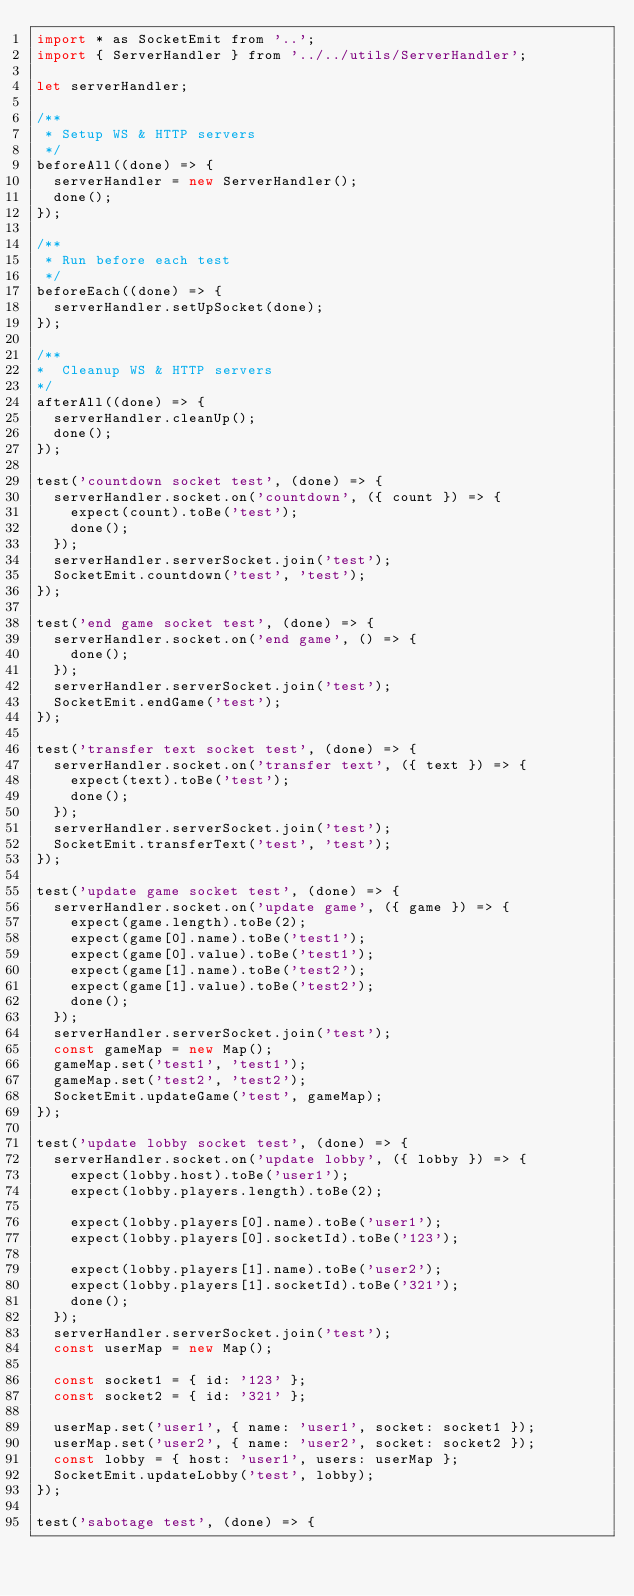<code> <loc_0><loc_0><loc_500><loc_500><_JavaScript_>import * as SocketEmit from '..';
import { ServerHandler } from '../../utils/ServerHandler';

let serverHandler;

/**
 * Setup WS & HTTP servers
 */
beforeAll((done) => {
  serverHandler = new ServerHandler();
  done();
});

/**
 * Run before each test
 */
beforeEach((done) => {
  serverHandler.setUpSocket(done);
});

/**
*  Cleanup WS & HTTP servers
*/
afterAll((done) => {
  serverHandler.cleanUp();
  done();
});

test('countdown socket test', (done) => {
  serverHandler.socket.on('countdown', ({ count }) => {
    expect(count).toBe('test');
    done();
  });
  serverHandler.serverSocket.join('test');
  SocketEmit.countdown('test', 'test');
});

test('end game socket test', (done) => {
  serverHandler.socket.on('end game', () => {
    done();
  });
  serverHandler.serverSocket.join('test');
  SocketEmit.endGame('test');
});

test('transfer text socket test', (done) => {
  serverHandler.socket.on('transfer text', ({ text }) => {
    expect(text).toBe('test');
    done();
  });
  serverHandler.serverSocket.join('test');
  SocketEmit.transferText('test', 'test');
});

test('update game socket test', (done) => {
  serverHandler.socket.on('update game', ({ game }) => {
    expect(game.length).toBe(2);
    expect(game[0].name).toBe('test1');
    expect(game[0].value).toBe('test1');
    expect(game[1].name).toBe('test2');
    expect(game[1].value).toBe('test2');
    done();
  });
  serverHandler.serverSocket.join('test');
  const gameMap = new Map();
  gameMap.set('test1', 'test1');
  gameMap.set('test2', 'test2');
  SocketEmit.updateGame('test', gameMap);
});

test('update lobby socket test', (done) => {
  serverHandler.socket.on('update lobby', ({ lobby }) => {
    expect(lobby.host).toBe('user1');
    expect(lobby.players.length).toBe(2);

    expect(lobby.players[0].name).toBe('user1');
    expect(lobby.players[0].socketId).toBe('123');

    expect(lobby.players[1].name).toBe('user2');
    expect(lobby.players[1].socketId).toBe('321');
    done();
  });
  serverHandler.serverSocket.join('test');
  const userMap = new Map();

  const socket1 = { id: '123' };
  const socket2 = { id: '321' };

  userMap.set('user1', { name: 'user1', socket: socket1 });
  userMap.set('user2', { name: 'user2', socket: socket2 });
  const lobby = { host: 'user1', users: userMap };
  SocketEmit.updateLobby('test', lobby);
});

test('sabotage test', (done) => {</code> 